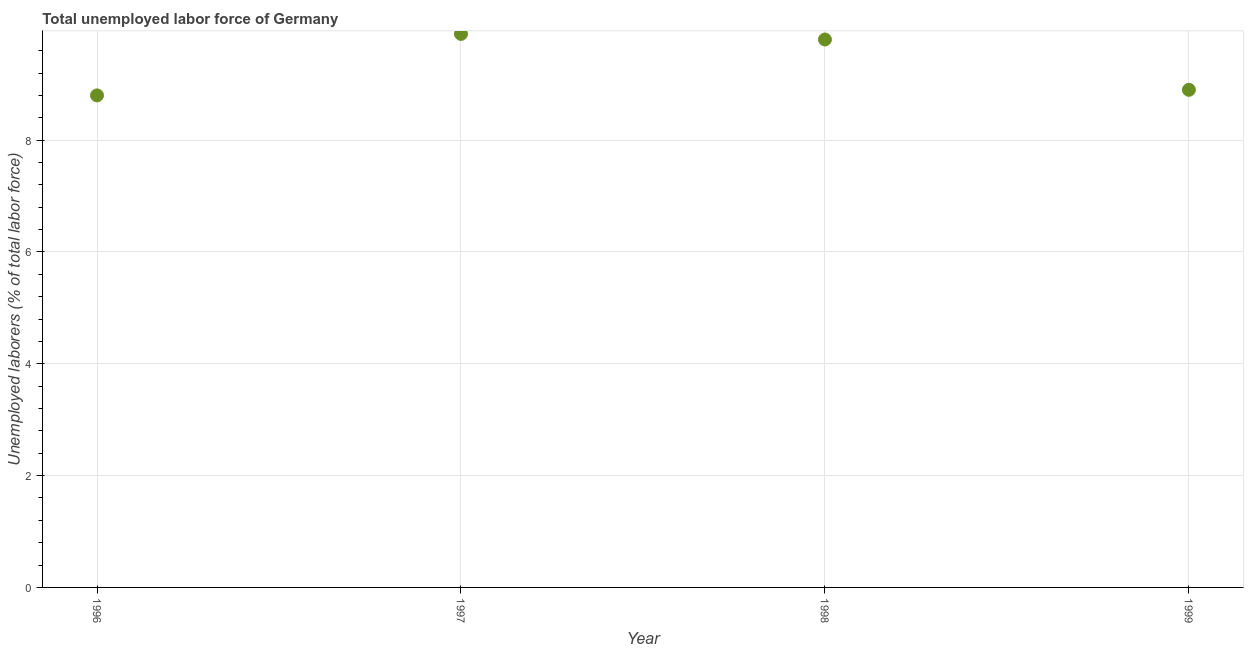What is the total unemployed labour force in 1999?
Ensure brevity in your answer.  8.9. Across all years, what is the maximum total unemployed labour force?
Keep it short and to the point. 9.9. Across all years, what is the minimum total unemployed labour force?
Your answer should be very brief. 8.8. In which year was the total unemployed labour force maximum?
Offer a very short reply. 1997. In which year was the total unemployed labour force minimum?
Your answer should be very brief. 1996. What is the sum of the total unemployed labour force?
Offer a terse response. 37.4. What is the difference between the total unemployed labour force in 1996 and 1999?
Make the answer very short. -0.1. What is the average total unemployed labour force per year?
Provide a short and direct response. 9.35. What is the median total unemployed labour force?
Your response must be concise. 9.35. In how many years, is the total unemployed labour force greater than 2.4 %?
Give a very brief answer. 4. What is the ratio of the total unemployed labour force in 1996 to that in 1998?
Provide a succinct answer. 0.9. Is the total unemployed labour force in 1996 less than that in 1999?
Provide a succinct answer. Yes. Is the difference between the total unemployed labour force in 1997 and 1998 greater than the difference between any two years?
Your answer should be compact. No. What is the difference between the highest and the second highest total unemployed labour force?
Provide a short and direct response. 0.1. Is the sum of the total unemployed labour force in 1997 and 1999 greater than the maximum total unemployed labour force across all years?
Ensure brevity in your answer.  Yes. What is the difference between the highest and the lowest total unemployed labour force?
Make the answer very short. 1.1. How many years are there in the graph?
Your response must be concise. 4. Does the graph contain any zero values?
Provide a short and direct response. No. Does the graph contain grids?
Offer a terse response. Yes. What is the title of the graph?
Offer a very short reply. Total unemployed labor force of Germany. What is the label or title of the X-axis?
Your answer should be very brief. Year. What is the label or title of the Y-axis?
Ensure brevity in your answer.  Unemployed laborers (% of total labor force). What is the Unemployed laborers (% of total labor force) in 1996?
Offer a very short reply. 8.8. What is the Unemployed laborers (% of total labor force) in 1997?
Keep it short and to the point. 9.9. What is the Unemployed laborers (% of total labor force) in 1998?
Provide a short and direct response. 9.8. What is the Unemployed laborers (% of total labor force) in 1999?
Offer a terse response. 8.9. What is the difference between the Unemployed laborers (% of total labor force) in 1996 and 1998?
Give a very brief answer. -1. What is the difference between the Unemployed laborers (% of total labor force) in 1997 and 1998?
Your response must be concise. 0.1. What is the difference between the Unemployed laborers (% of total labor force) in 1997 and 1999?
Offer a terse response. 1. What is the difference between the Unemployed laborers (% of total labor force) in 1998 and 1999?
Your answer should be very brief. 0.9. What is the ratio of the Unemployed laborers (% of total labor force) in 1996 to that in 1997?
Keep it short and to the point. 0.89. What is the ratio of the Unemployed laborers (% of total labor force) in 1996 to that in 1998?
Keep it short and to the point. 0.9. What is the ratio of the Unemployed laborers (% of total labor force) in 1996 to that in 1999?
Ensure brevity in your answer.  0.99. What is the ratio of the Unemployed laborers (% of total labor force) in 1997 to that in 1999?
Ensure brevity in your answer.  1.11. What is the ratio of the Unemployed laborers (% of total labor force) in 1998 to that in 1999?
Provide a succinct answer. 1.1. 